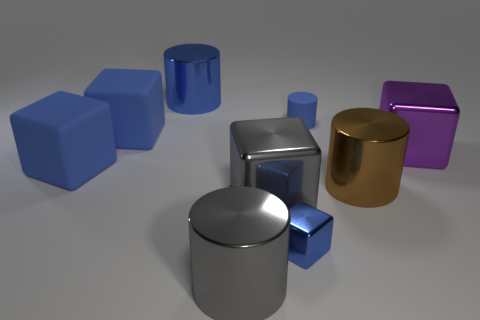Subtract all purple cubes. How many cubes are left? 4 Subtract all gray cubes. How many cubes are left? 4 Subtract 4 cubes. How many cubes are left? 1 Add 3 blue metallic cylinders. How many blue metallic cylinders are left? 4 Add 4 purple objects. How many purple objects exist? 5 Add 1 large cyan rubber cylinders. How many objects exist? 10 Subtract 1 gray blocks. How many objects are left? 8 Subtract all cylinders. How many objects are left? 5 Subtract all purple blocks. Subtract all gray balls. How many blocks are left? 4 Subtract all yellow spheres. How many brown cylinders are left? 1 